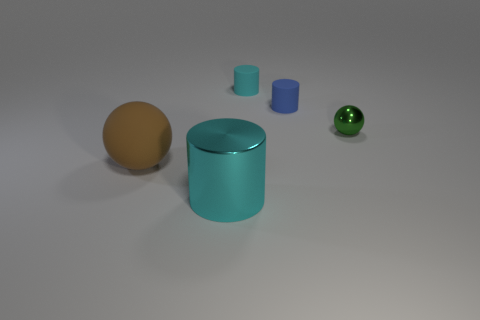Is there any other thing that is the same shape as the tiny cyan thing?
Offer a terse response. Yes. Are there the same number of green metal spheres that are on the right side of the small cyan cylinder and brown rubber balls behind the blue object?
Provide a short and direct response. No. How many cylinders are large cyan metal things or brown rubber objects?
Offer a very short reply. 1. How many other things are made of the same material as the brown ball?
Your answer should be very brief. 2. There is a shiny thing behind the brown matte thing; what shape is it?
Offer a terse response. Sphere. What material is the ball in front of the ball behind the brown matte ball?
Offer a very short reply. Rubber. Is the number of metallic spheres on the left side of the tiny cyan rubber cylinder greater than the number of tiny cyan cylinders?
Provide a succinct answer. No. What number of other objects are the same color as the big cylinder?
Give a very brief answer. 1. There is a green metal thing that is the same size as the blue rubber cylinder; what shape is it?
Give a very brief answer. Sphere. How many cyan rubber objects are behind the cyan cylinder that is in front of the rubber object left of the cyan shiny cylinder?
Provide a short and direct response. 1. 